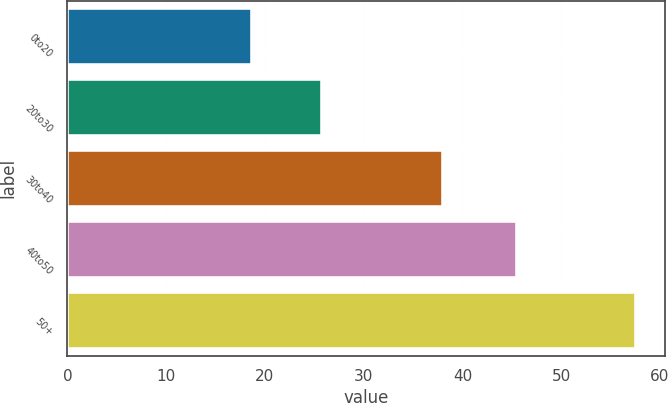Convert chart. <chart><loc_0><loc_0><loc_500><loc_500><bar_chart><fcel>0to20<fcel>20to30<fcel>30to40<fcel>40to50<fcel>50+<nl><fcel>18.67<fcel>25.83<fcel>38.05<fcel>45.54<fcel>57.6<nl></chart> 